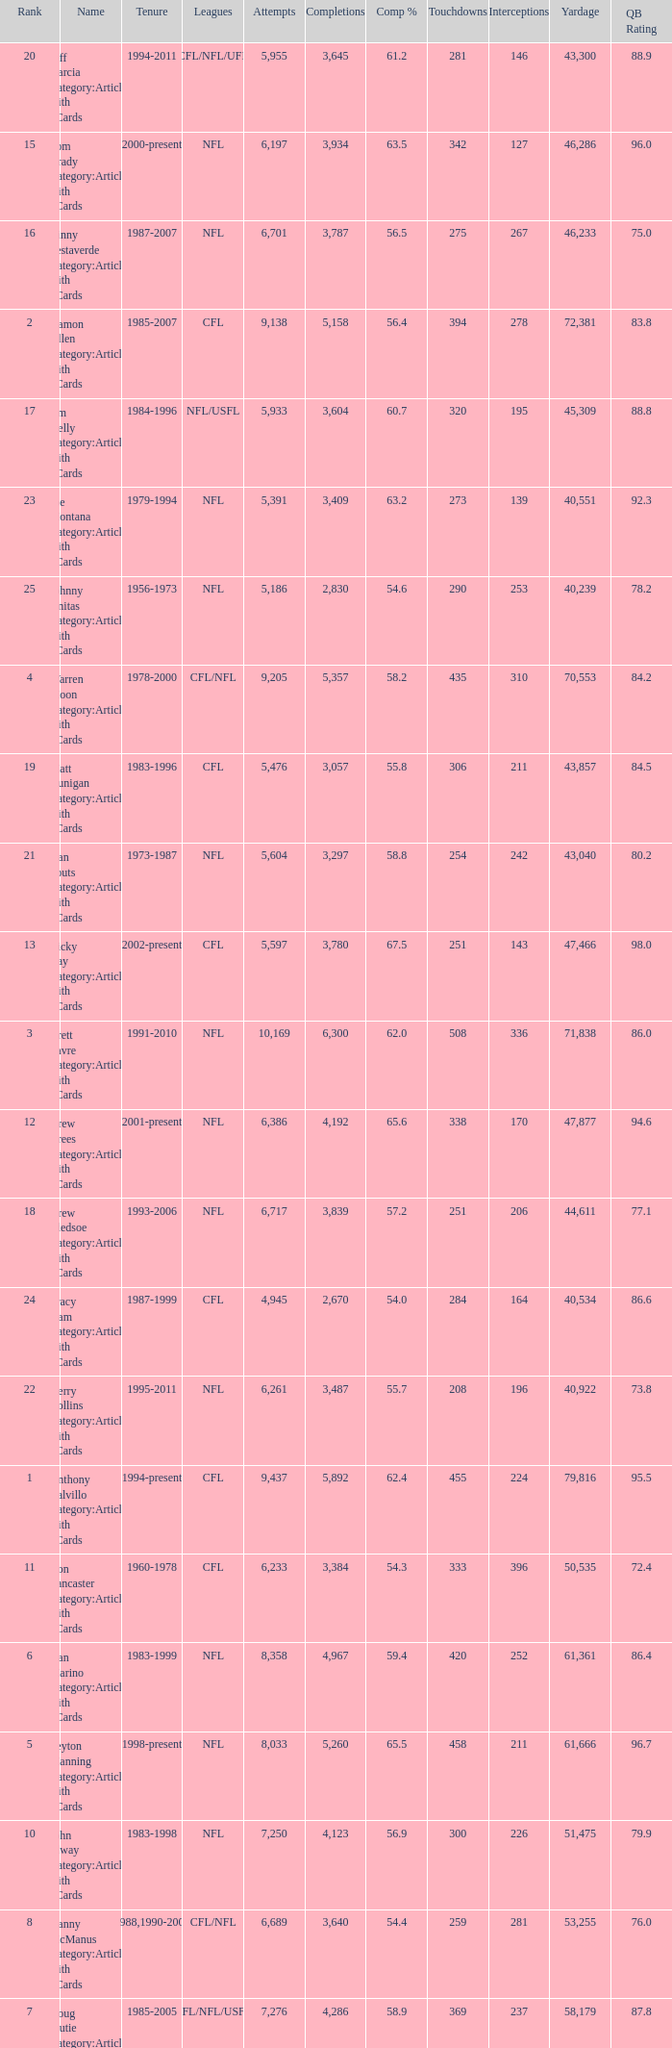What is the number of interceptions with less than 3,487 completions , more than 40,551 yardage, and the comp % is 55.8? 211.0. 